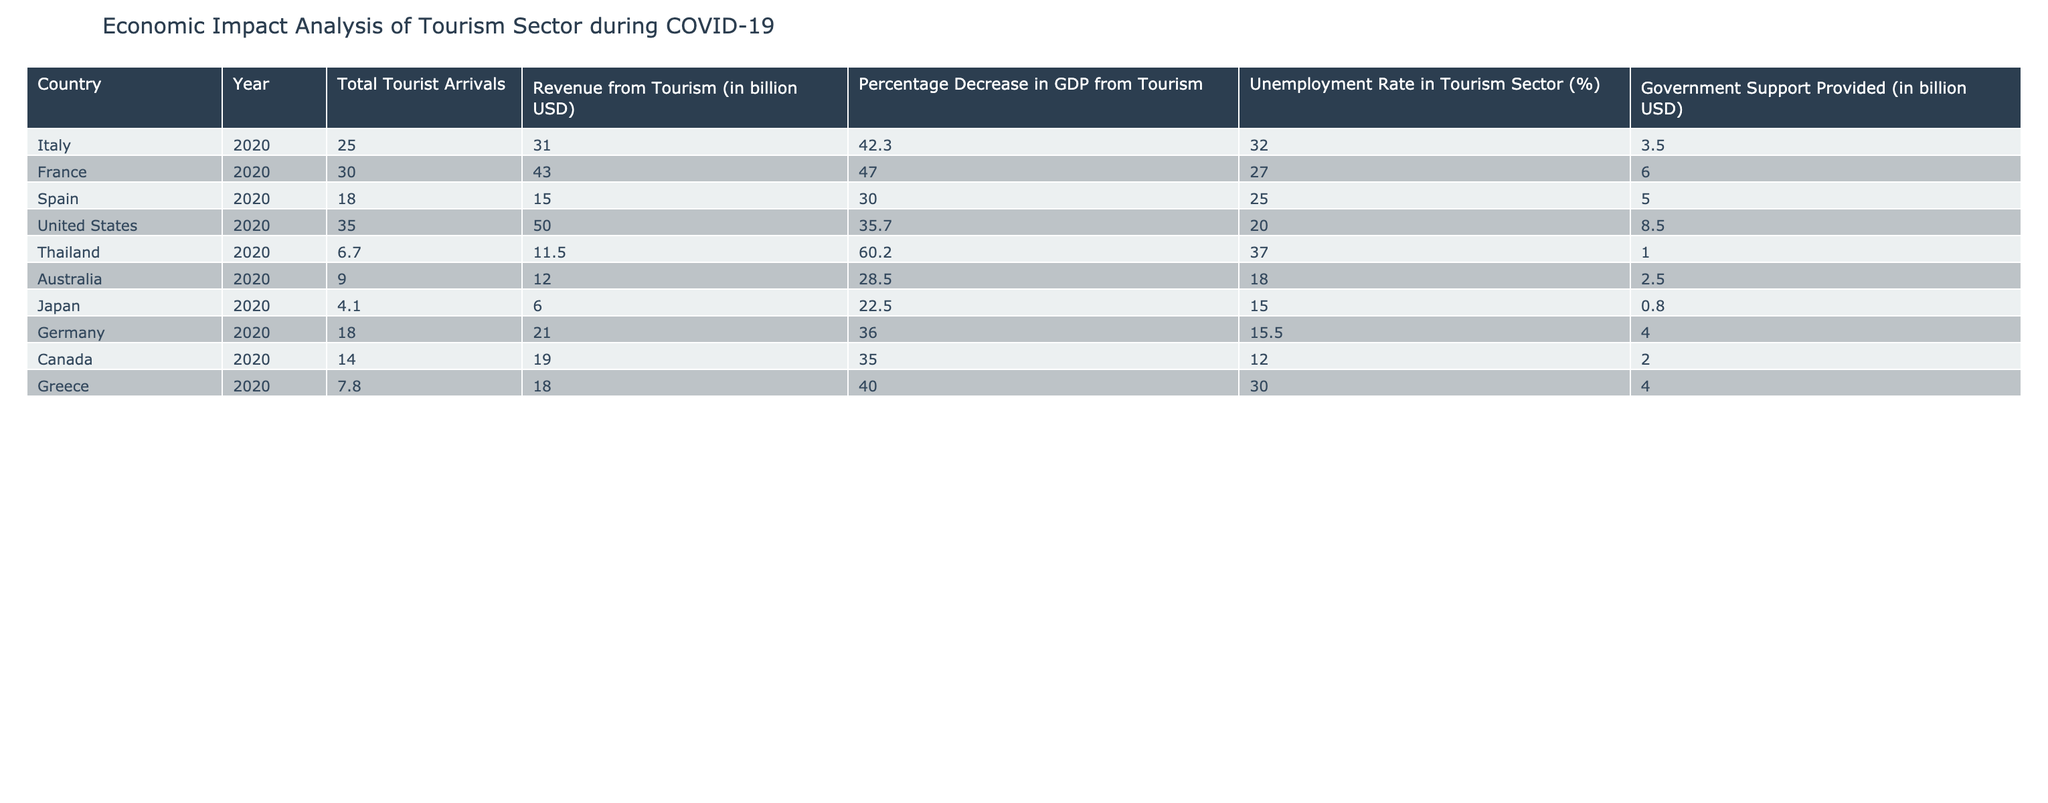What was the total revenue from tourism in France in 2020? The table shows that in 2020, France generated revenue from tourism amounting to 43.0 billion USD. This value is presented directly in the "Revenue from Tourism (in billion USD)" column for the row corresponding to France.
Answer: 43.0 billion USD Which country had the highest unemployment rate in the tourism sector in 2020? By examining the "Unemployment Rate in Tourism Sector (%)" column, we see that Thailand had the highest unemployment rate at 37.0%, as it's greater than the other countries listed.
Answer: Thailand What is the average percentage decrease in GDP from tourism across all listed countries? To calculate the average, sum the percentage decreases for all countries: (42.3 + 47.0 + 30.0 + 35.7 + 60.2 + 28.5 + 22.5 + 36.0 + 35.0 + 40.0) =  402.2 and divide by the number of countries (10): 402.2 / 10 = 40.22%.
Answer: 40.2% Is it true that the total tourist arrivals in Germany were greater than both Italy and Spain in 2020? From the table, Germany had 18.0 million tourist arrivals, Italy had 25.0 million, and Spain had 18.0 million in the same year. Therefore, it is false that Germany's arrivals were greater than both of them.
Answer: No What was the government support provided for tourism in the United States relative to its revenue from tourism? According to the table, the government support in the United States amounted to 8.5 billion USD, while its revenue was 50.0 billion USD. To find the ratio, you can compare the amounts; thus, the support is significantly lower than the revenue.
Answer: 8.5 billion USD 